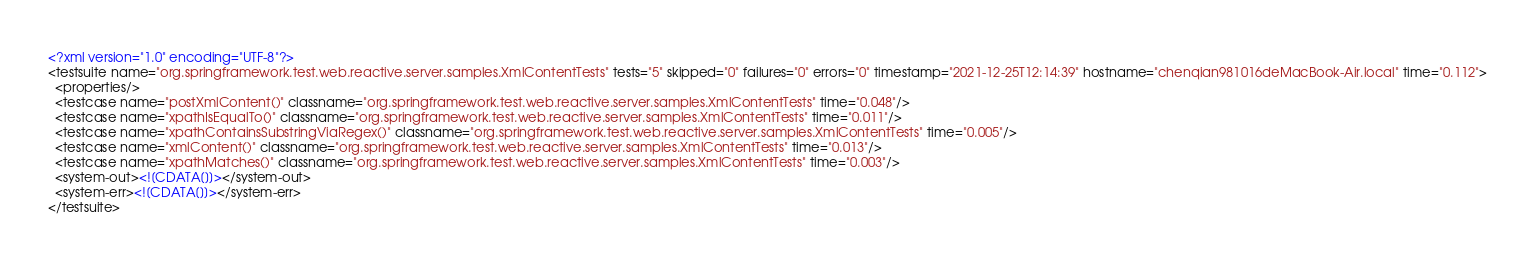Convert code to text. <code><loc_0><loc_0><loc_500><loc_500><_XML_><?xml version="1.0" encoding="UTF-8"?>
<testsuite name="org.springframework.test.web.reactive.server.samples.XmlContentTests" tests="5" skipped="0" failures="0" errors="0" timestamp="2021-12-25T12:14:39" hostname="chenqian981016deMacBook-Air.local" time="0.112">
  <properties/>
  <testcase name="postXmlContent()" classname="org.springframework.test.web.reactive.server.samples.XmlContentTests" time="0.048"/>
  <testcase name="xpathIsEqualTo()" classname="org.springframework.test.web.reactive.server.samples.XmlContentTests" time="0.011"/>
  <testcase name="xpathContainsSubstringViaRegex()" classname="org.springframework.test.web.reactive.server.samples.XmlContentTests" time="0.005"/>
  <testcase name="xmlContent()" classname="org.springframework.test.web.reactive.server.samples.XmlContentTests" time="0.013"/>
  <testcase name="xpathMatches()" classname="org.springframework.test.web.reactive.server.samples.XmlContentTests" time="0.003"/>
  <system-out><![CDATA[]]></system-out>
  <system-err><![CDATA[]]></system-err>
</testsuite>
</code> 